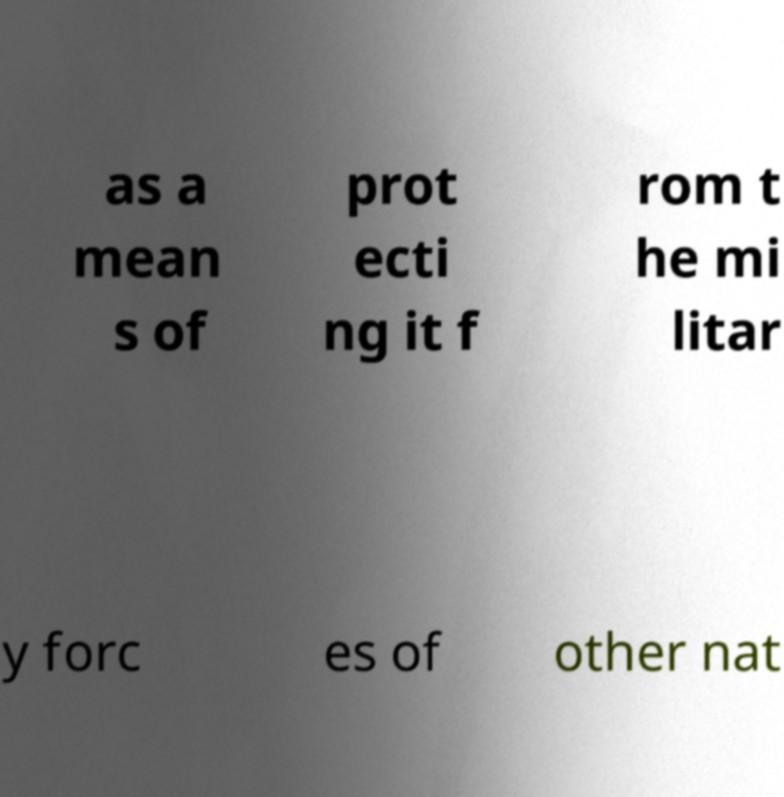Please identify and transcribe the text found in this image. as a mean s of prot ecti ng it f rom t he mi litar y forc es of other nat 